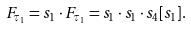<formula> <loc_0><loc_0><loc_500><loc_500>F _ { \tau _ { 1 } } & = s _ { 1 } \cdot F _ { \tau _ { 1 } } = s _ { 1 } \cdot s _ { 1 } \cdot s _ { 4 } [ s _ { 1 } ] .</formula> 